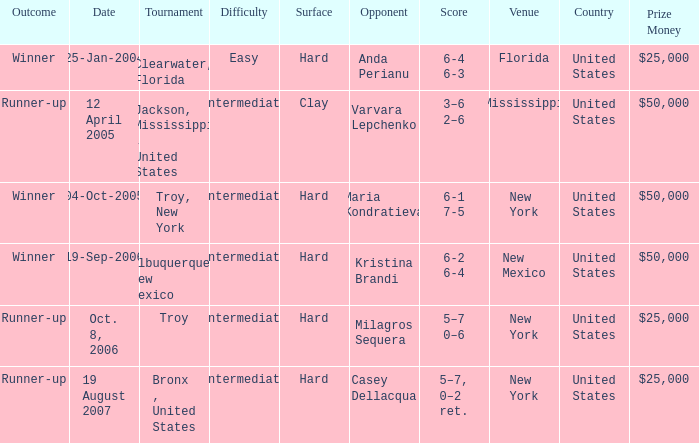What was the surface of the game that resulted in a final score of 6-1 7-5? Hard. 